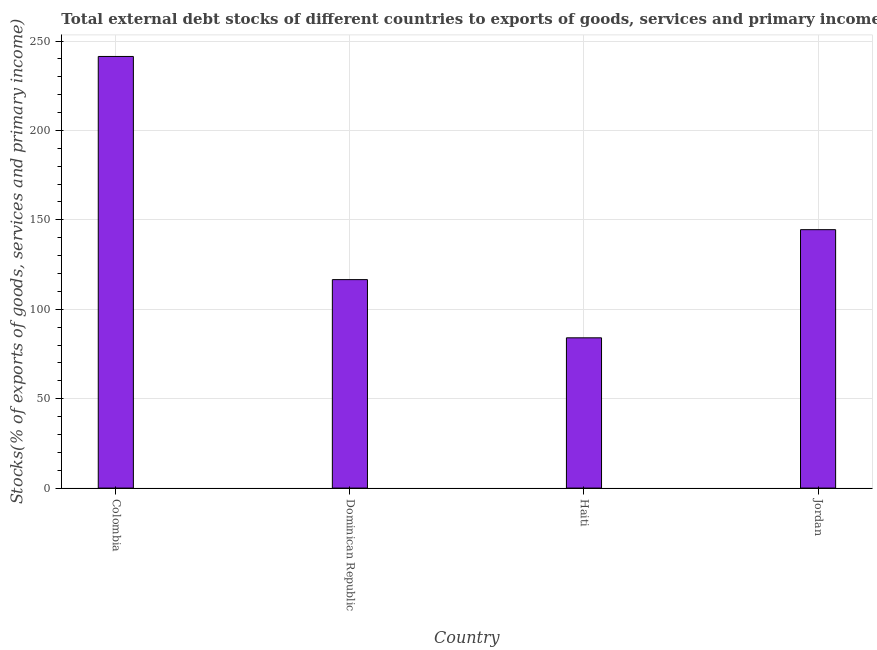Does the graph contain any zero values?
Keep it short and to the point. No. Does the graph contain grids?
Give a very brief answer. Yes. What is the title of the graph?
Provide a short and direct response. Total external debt stocks of different countries to exports of goods, services and primary income in 1972. What is the label or title of the X-axis?
Offer a terse response. Country. What is the label or title of the Y-axis?
Keep it short and to the point. Stocks(% of exports of goods, services and primary income). What is the external debt stocks in Dominican Republic?
Your answer should be compact. 116.58. Across all countries, what is the maximum external debt stocks?
Your response must be concise. 241.37. Across all countries, what is the minimum external debt stocks?
Ensure brevity in your answer.  84.03. In which country was the external debt stocks minimum?
Provide a succinct answer. Haiti. What is the sum of the external debt stocks?
Offer a terse response. 586.49. What is the difference between the external debt stocks in Dominican Republic and Haiti?
Keep it short and to the point. 32.55. What is the average external debt stocks per country?
Give a very brief answer. 146.62. What is the median external debt stocks?
Make the answer very short. 130.54. What is the ratio of the external debt stocks in Colombia to that in Jordan?
Your answer should be very brief. 1.67. Is the external debt stocks in Dominican Republic less than that in Jordan?
Give a very brief answer. Yes. What is the difference between the highest and the second highest external debt stocks?
Your answer should be very brief. 96.86. What is the difference between the highest and the lowest external debt stocks?
Offer a terse response. 157.34. In how many countries, is the external debt stocks greater than the average external debt stocks taken over all countries?
Offer a terse response. 1. What is the difference between two consecutive major ticks on the Y-axis?
Offer a terse response. 50. What is the Stocks(% of exports of goods, services and primary income) in Colombia?
Give a very brief answer. 241.37. What is the Stocks(% of exports of goods, services and primary income) of Dominican Republic?
Your answer should be very brief. 116.58. What is the Stocks(% of exports of goods, services and primary income) of Haiti?
Make the answer very short. 84.03. What is the Stocks(% of exports of goods, services and primary income) in Jordan?
Keep it short and to the point. 144.51. What is the difference between the Stocks(% of exports of goods, services and primary income) in Colombia and Dominican Republic?
Provide a short and direct response. 124.79. What is the difference between the Stocks(% of exports of goods, services and primary income) in Colombia and Haiti?
Provide a succinct answer. 157.34. What is the difference between the Stocks(% of exports of goods, services and primary income) in Colombia and Jordan?
Provide a short and direct response. 96.86. What is the difference between the Stocks(% of exports of goods, services and primary income) in Dominican Republic and Haiti?
Your answer should be compact. 32.55. What is the difference between the Stocks(% of exports of goods, services and primary income) in Dominican Republic and Jordan?
Offer a very short reply. -27.93. What is the difference between the Stocks(% of exports of goods, services and primary income) in Haiti and Jordan?
Offer a terse response. -60.48. What is the ratio of the Stocks(% of exports of goods, services and primary income) in Colombia to that in Dominican Republic?
Offer a very short reply. 2.07. What is the ratio of the Stocks(% of exports of goods, services and primary income) in Colombia to that in Haiti?
Your response must be concise. 2.87. What is the ratio of the Stocks(% of exports of goods, services and primary income) in Colombia to that in Jordan?
Your answer should be very brief. 1.67. What is the ratio of the Stocks(% of exports of goods, services and primary income) in Dominican Republic to that in Haiti?
Make the answer very short. 1.39. What is the ratio of the Stocks(% of exports of goods, services and primary income) in Dominican Republic to that in Jordan?
Provide a succinct answer. 0.81. What is the ratio of the Stocks(% of exports of goods, services and primary income) in Haiti to that in Jordan?
Keep it short and to the point. 0.58. 